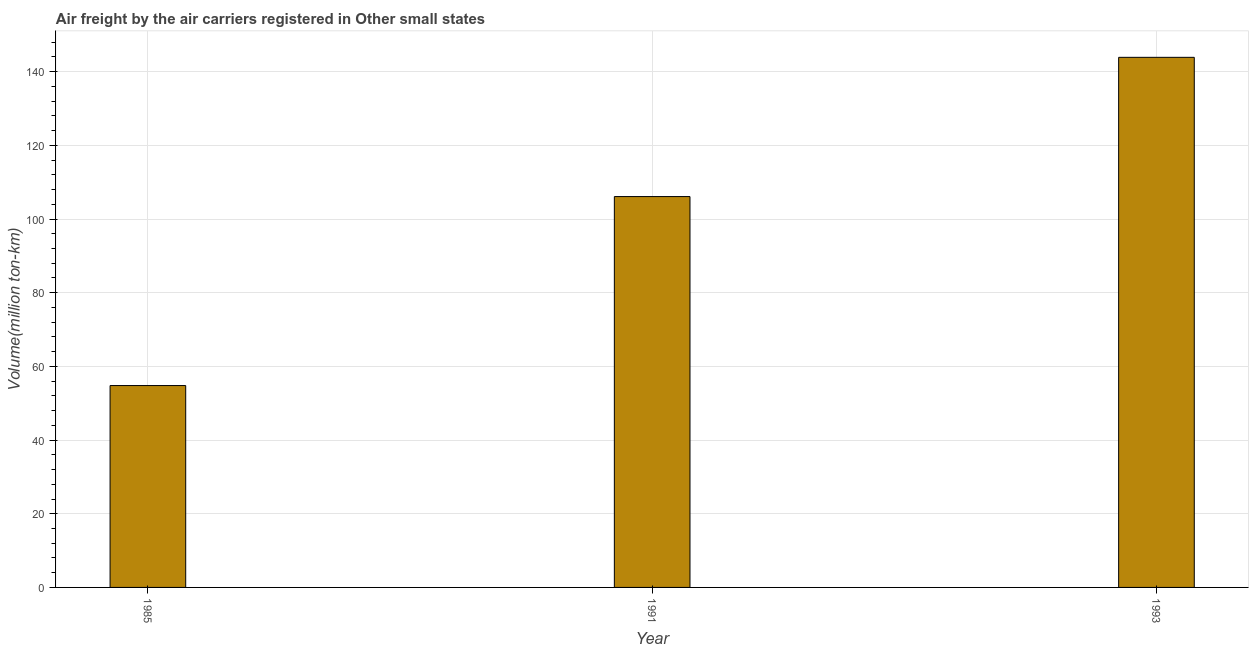Does the graph contain any zero values?
Your answer should be very brief. No. Does the graph contain grids?
Provide a short and direct response. Yes. What is the title of the graph?
Provide a succinct answer. Air freight by the air carriers registered in Other small states. What is the label or title of the Y-axis?
Your answer should be very brief. Volume(million ton-km). What is the air freight in 1993?
Provide a succinct answer. 143.9. Across all years, what is the maximum air freight?
Keep it short and to the point. 143.9. Across all years, what is the minimum air freight?
Your answer should be compact. 54.8. In which year was the air freight minimum?
Keep it short and to the point. 1985. What is the sum of the air freight?
Your response must be concise. 304.8. What is the difference between the air freight in 1985 and 1993?
Your answer should be compact. -89.1. What is the average air freight per year?
Make the answer very short. 101.6. What is the median air freight?
Offer a very short reply. 106.1. What is the ratio of the air freight in 1985 to that in 1991?
Give a very brief answer. 0.52. What is the difference between the highest and the second highest air freight?
Your answer should be very brief. 37.8. Is the sum of the air freight in 1985 and 1991 greater than the maximum air freight across all years?
Provide a succinct answer. Yes. What is the difference between the highest and the lowest air freight?
Give a very brief answer. 89.1. In how many years, is the air freight greater than the average air freight taken over all years?
Your answer should be compact. 2. How many bars are there?
Your response must be concise. 3. Are all the bars in the graph horizontal?
Keep it short and to the point. No. What is the difference between two consecutive major ticks on the Y-axis?
Your answer should be compact. 20. Are the values on the major ticks of Y-axis written in scientific E-notation?
Your answer should be very brief. No. What is the Volume(million ton-km) in 1985?
Provide a short and direct response. 54.8. What is the Volume(million ton-km) in 1991?
Provide a short and direct response. 106.1. What is the Volume(million ton-km) of 1993?
Offer a terse response. 143.9. What is the difference between the Volume(million ton-km) in 1985 and 1991?
Make the answer very short. -51.3. What is the difference between the Volume(million ton-km) in 1985 and 1993?
Your answer should be very brief. -89.1. What is the difference between the Volume(million ton-km) in 1991 and 1993?
Your answer should be compact. -37.8. What is the ratio of the Volume(million ton-km) in 1985 to that in 1991?
Provide a succinct answer. 0.52. What is the ratio of the Volume(million ton-km) in 1985 to that in 1993?
Keep it short and to the point. 0.38. What is the ratio of the Volume(million ton-km) in 1991 to that in 1993?
Keep it short and to the point. 0.74. 